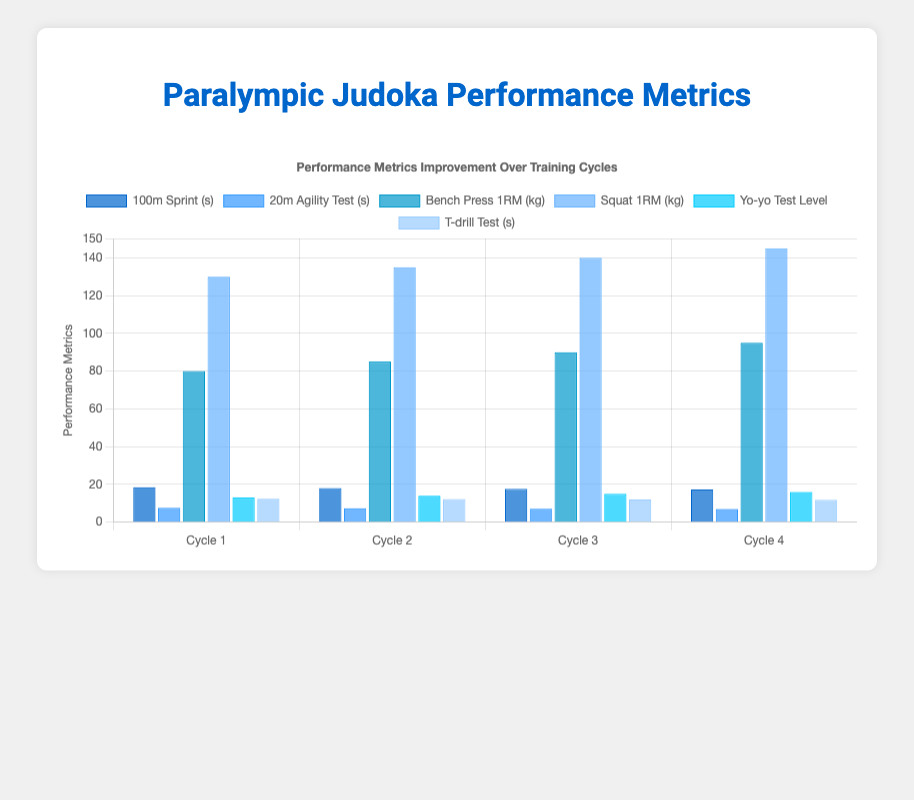What is the trend in the 100m sprint times across the training cycles? Observing the 100m sprint times, the times decrease from Cycle 1 (18.5 seconds) to Cycle 4 (17.3 seconds). This indicates an improvement in sprint speed over the training cycles.
Answer: Improvement in speed (times decrease) Which training cycle shows the highest bench press 1RM? By looking at the height of the bars for the bench press 1RM across cycles, Cycle 4 has the highest value with 95 kg.
Answer: Cycle 4 Compare the T-drill test scores between Cycle 2 and Cycle 4. Which cycle has better performance? T-drill test scores are indicated by lower values for better performance. In Cycle 2, it is 12.2 seconds, while in Cycle 4 it is 11.8 seconds. Therefore, Cycle 4 has better performance.
Answer: Cycle 4 How many values show an improvement in Cycle 3 compared to Cycle 2 in any metric? In Cycle 3 compared to Cycle 2, 100m sprint (time decreases), 20m agility test (time decreases), bench press (kg increases), squat (kg increases), yo-yo test level (level increases), and T-drill test (time decreases) all show improvement. That's 6 values improving.
Answer: 6 values On average, how much did the squat 1RM increase from one cycle to the next? The squat 1RM values are 130 kg (Cycle 1), 135 kg (Cycle 2), 140 kg (Cycle 3), and 145 kg (Cycle 4). The increases are 5 kg (Cycle 1 to 2), 5 kg (Cycle 2 to 3), and 5 kg (Cycle 3 to 4). The average increase is (5+5+5) / 3 = 5 kg.
Answer: 5 kg Which speed metric shows the greatest relative improvement from Cycle 1 to Cycle 4? The 100m sprint improves from 18.5 to 17.3 seconds (1.2 seconds improvement), whereas the 20m agility test improves from 7.6 to 7.0 seconds (0.6 seconds improvement). The 100m sprint shows a greater improvement.
Answer: 100m sprint What is the average Yo-yo test level from Cycle 1 to Cycle 4? Adding the Yo-yo test levels for each cycle: 13 (Cycle 1), 14 (Cycle 2), 15 (Cycle 3), 16 (Cycle 4), the total is 58. Dividing by 4 cycles gives an average of 14.5.
Answer: 14.5 Visually comparing the datasets, which visual element indicates the metric 'squat 1RM (kg)' on the chart? The color and height of the bars can be observed for this metric. 'Squat 1RM' has bars that are light blue in color and increase in height consecutively from Cycle 1 to Cycle 4.
Answer: Light blue bars Which metric shows the least improvement across the training cycles? By observing the smallest difference in bar heights across cycles, the '20m agility test' with a decrease from 7.6 seconds (Cycle 1) to 7.0 seconds (Cycle 4) shows the least visual improvement.
Answer: 20m agility test How does the performance in the yo-yo test level change visually across the cycles? The yo-yo test level bars, cyan in color, increase in height consistently from Cycle 1 (13) to Cycle 4 (16), indicating improvement.
Answer: Improvement (bars increase) 